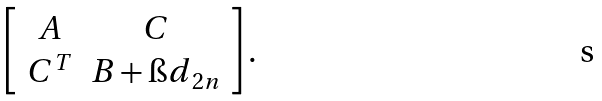Convert formula to latex. <formula><loc_0><loc_0><loc_500><loc_500>\left [ \begin{array} { c c } A & C \\ C ^ { T } & B + { \i d } _ { 2 n } \end{array} \right ] .</formula> 